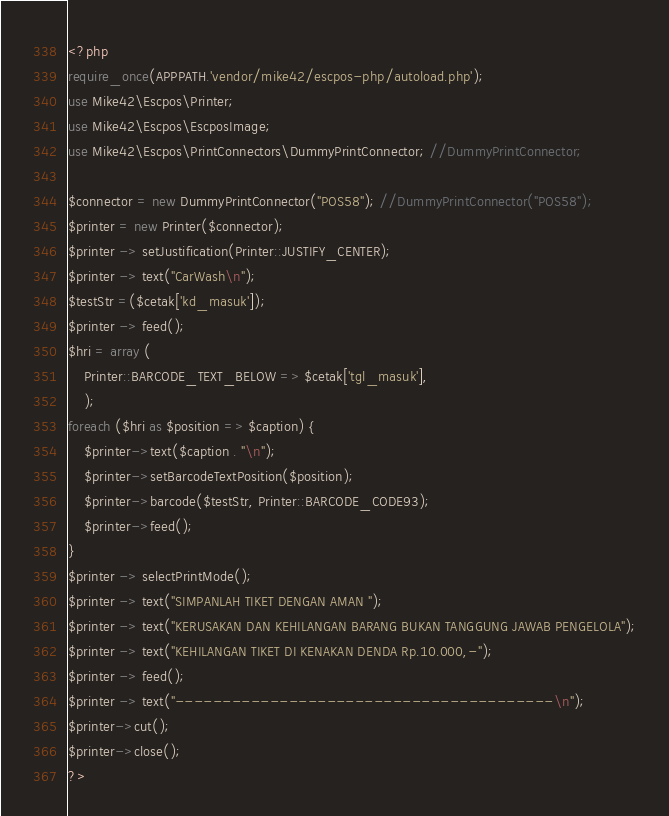Convert code to text. <code><loc_0><loc_0><loc_500><loc_500><_PHP_><?php
require_once(APPPATH.'vendor/mike42/escpos-php/autoload.php');
use Mike42\Escpos\Printer;
use Mike42\Escpos\EscposImage;
use Mike42\Escpos\PrintConnectors\DummyPrintConnector; //DummyPrintConnector;

$connector = new DummyPrintConnector("POS58"); //DummyPrintConnector("POS58");
$printer = new Printer($connector);
$printer -> setJustification(Printer::JUSTIFY_CENTER);
$printer -> text("CarWash\n");
$testStr =($cetak['kd_masuk']);
$printer -> feed();
$hri = array (
    Printer::BARCODE_TEXT_BELOW => $cetak['tgl_masuk'],
    );
foreach ($hri as $position => $caption) {
    $printer->text($caption . "\n");
    $printer->setBarcodeTextPosition($position);
    $printer->barcode($testStr, Printer::BARCODE_CODE93);
    $printer->feed();
}
$printer -> selectPrintMode();
$printer -> text("SIMPANLAH TIKET DENGAN AMAN ");
$printer -> text("KERUSAKAN DAN KEHILANGAN BARANG BUKAN TANGGUNG JAWAB PENGELOLA");
$printer -> text("KEHILANGAN TIKET DI KENAKAN DENDA Rp.10.000,-");
$printer -> feed();
$printer -> text("----------------------------------------\n");
$printer->cut();
$printer->close();
?>
</code> 